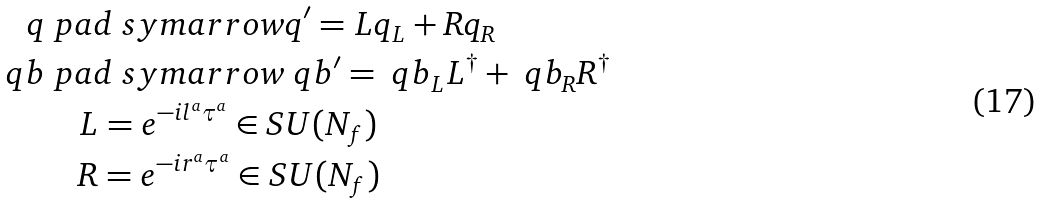<formula> <loc_0><loc_0><loc_500><loc_500>q & \ p a d { \ s y m a r r o w } q ^ { \prime } = L q _ { L } + R q _ { R } \\ \ q b & \ p a d { \ s y m a r r o w } \ q b ^ { \prime } = \ q b _ { L } L ^ { \dagger } + \ q b _ { R } R ^ { \dagger } \\ & \quad L = e ^ { - i l ^ { a } \tau ^ { a } } \in S U ( N _ { f } ) \\ & \quad R = e ^ { - i r ^ { a } \tau ^ { a } } \in S U ( N _ { f } )</formula> 